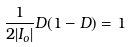Convert formula to latex. <formula><loc_0><loc_0><loc_500><loc_500>\frac { 1 } { 2 | I _ { o } | } D ( 1 - D ) = 1</formula> 